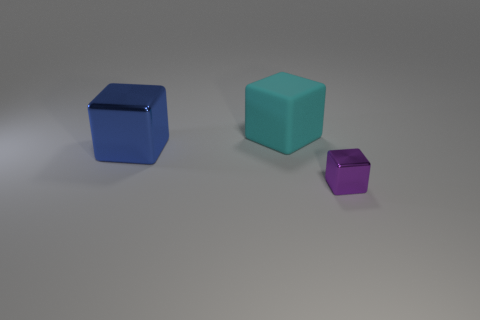Is there any other thing that is the same size as the purple cube?
Your answer should be very brief. No. What number of metal objects are either small cubes or blocks?
Offer a very short reply. 2. Is there anything else that is the same shape as the small metallic thing?
Make the answer very short. Yes. There is a small thing on the right side of the cyan object; what material is it?
Provide a succinct answer. Metal. Are the block that is in front of the big metal thing and the big cyan block made of the same material?
Offer a terse response. No. What number of things are either big blue blocks or blocks behind the purple thing?
Make the answer very short. 2. There is another metal object that is the same shape as the tiny purple thing; what size is it?
Provide a short and direct response. Large. Are there any purple metal cubes to the right of the large cyan cube?
Your answer should be compact. Yes. There is a big cube that is behind the blue thing; does it have the same color as the block that is on the left side of the matte thing?
Your answer should be compact. No. Are there any other things that have the same shape as the big metallic thing?
Your answer should be very brief. Yes. 